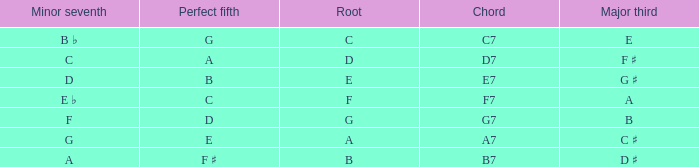What is the Major third with a Perfect fifth that is d? B. 